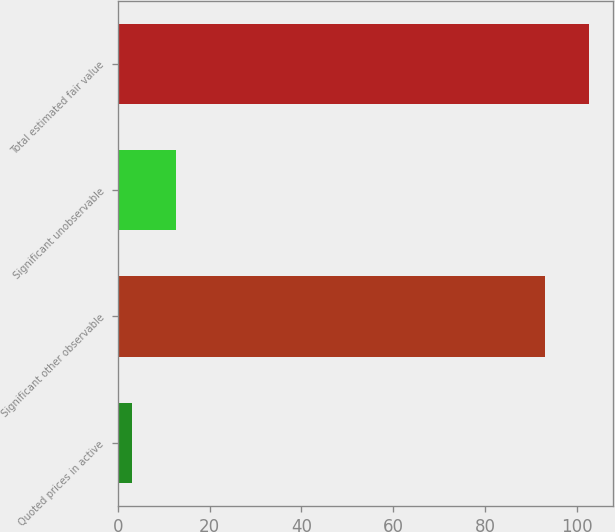Convert chart to OTSL. <chart><loc_0><loc_0><loc_500><loc_500><bar_chart><fcel>Quoted prices in active<fcel>Significant other observable<fcel>Significant unobservable<fcel>Total estimated fair value<nl><fcel>3<fcel>93<fcel>12.7<fcel>102.7<nl></chart> 